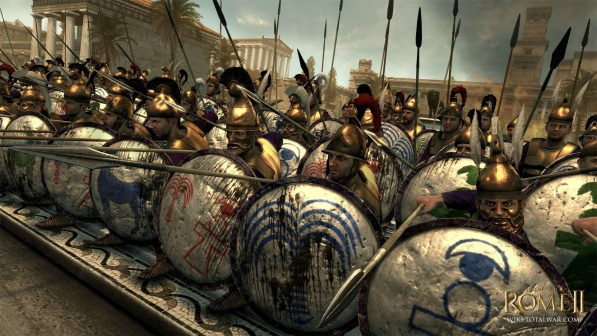Write a detailed description of the given image.
 The image captures a scene from the video game Rome II: Total War. In the foreground, a group of soldiers stands in a phalanx formation, their bodies protected by armor and their heads adorned with plumed helmets. Each soldier holds a spear in one hand and a shield in the other, the latter decorated with patterns in blue and white. 

The soldiers are positioned in such a way that their spears are ready for an attack, pointing towards the sky in a hazy blue color. The shields, held firmly, form a wall of defense, their blue and white patterns adding a touch of color to the otherwise metallic ensemble.

In the background, the cityscape unfolds with buildings and columns, reminiscent of ancient Roman architecture. The precise location of these structures is hard to determine from the image, but they appear to be situated at a distance from the phalanx formation, providing a backdrop to the military scene.

There is no discernible text in the image, and the relative positions of the objects suggest a scene of preparation or standoff in the game. The image does not provide information on the number of soldiers, but the phalanx formation suggests a sizable force. The image is devoid of any aesthetic descriptions, focusing solely on the factual representation of the game scene. 